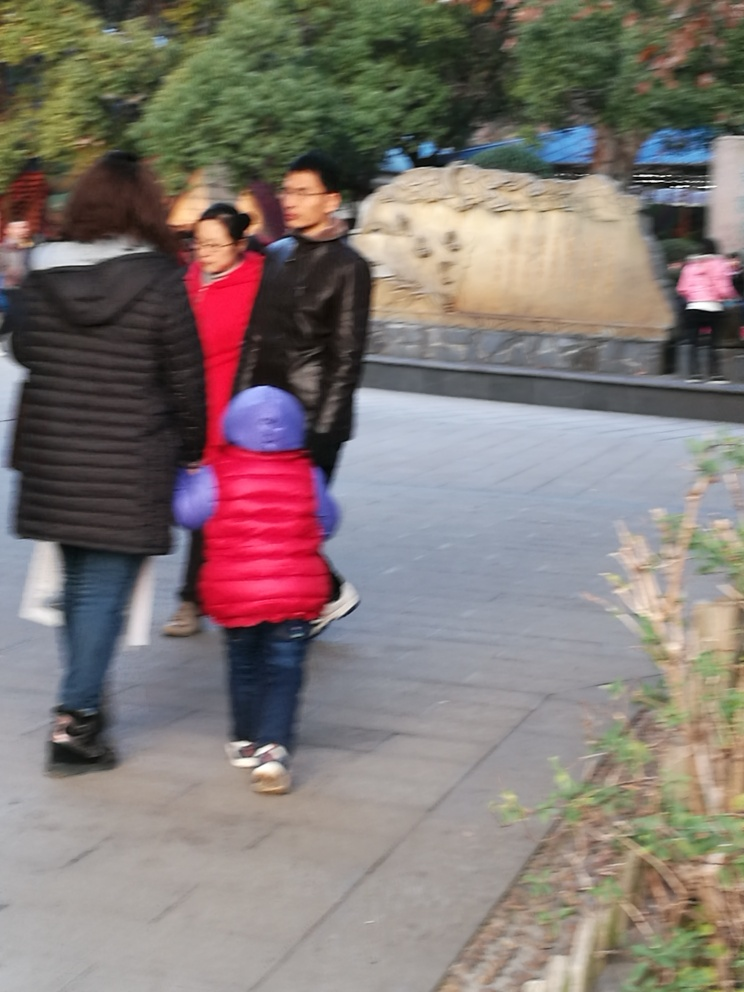What makes it hard to distinguish the subject in this image?
A. clear outlines
B. blurry outlines
C. high resolution It's difficult to distinguish the subject in this image due to the blurry outlines of the figures. This lack of clarity could be the result of motion blur, a low shutter speed, or an unfocused camera, making the image appear less sharp and the subjects less defined. 